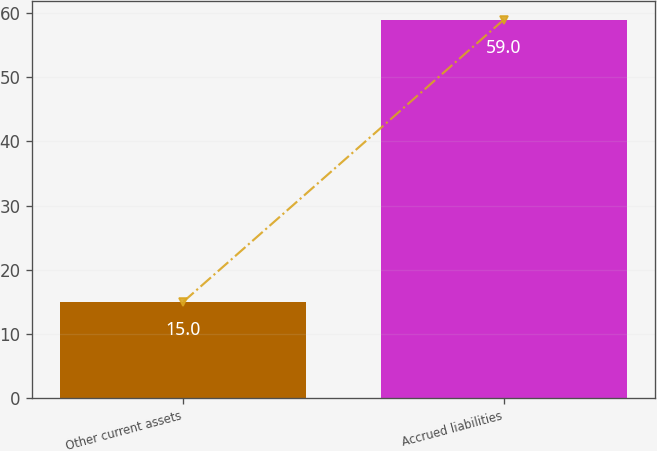Convert chart to OTSL. <chart><loc_0><loc_0><loc_500><loc_500><bar_chart><fcel>Other current assets<fcel>Accrued liabilities<nl><fcel>15<fcel>59<nl></chart> 